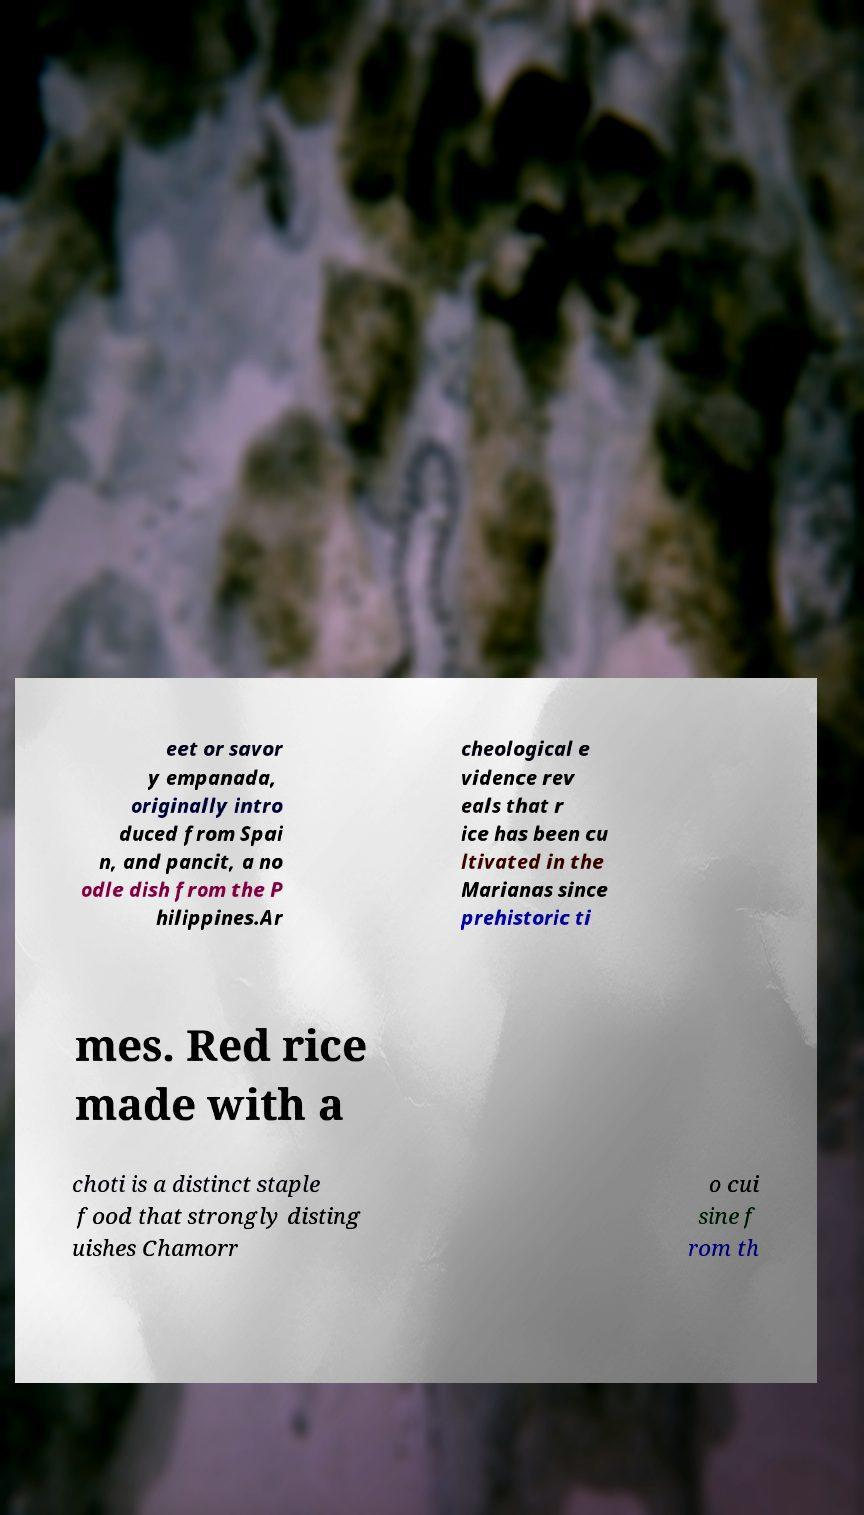Could you assist in decoding the text presented in this image and type it out clearly? eet or savor y empanada, originally intro duced from Spai n, and pancit, a no odle dish from the P hilippines.Ar cheological e vidence rev eals that r ice has been cu ltivated in the Marianas since prehistoric ti mes. Red rice made with a choti is a distinct staple food that strongly disting uishes Chamorr o cui sine f rom th 